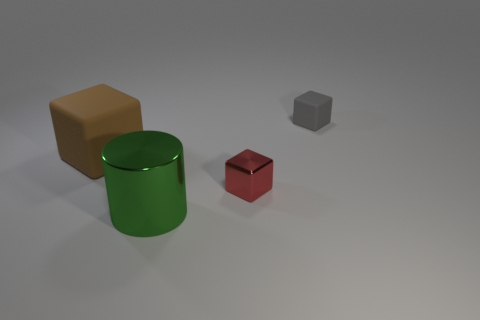Are there any large metal things that have the same color as the large rubber block? In the image, none of the objects appear to be large metal things that share the same color as the large rubber block. The large rubber block is of a distinct brown color and the only other large object in the image is a green cylindrical object, which does not match in color. 